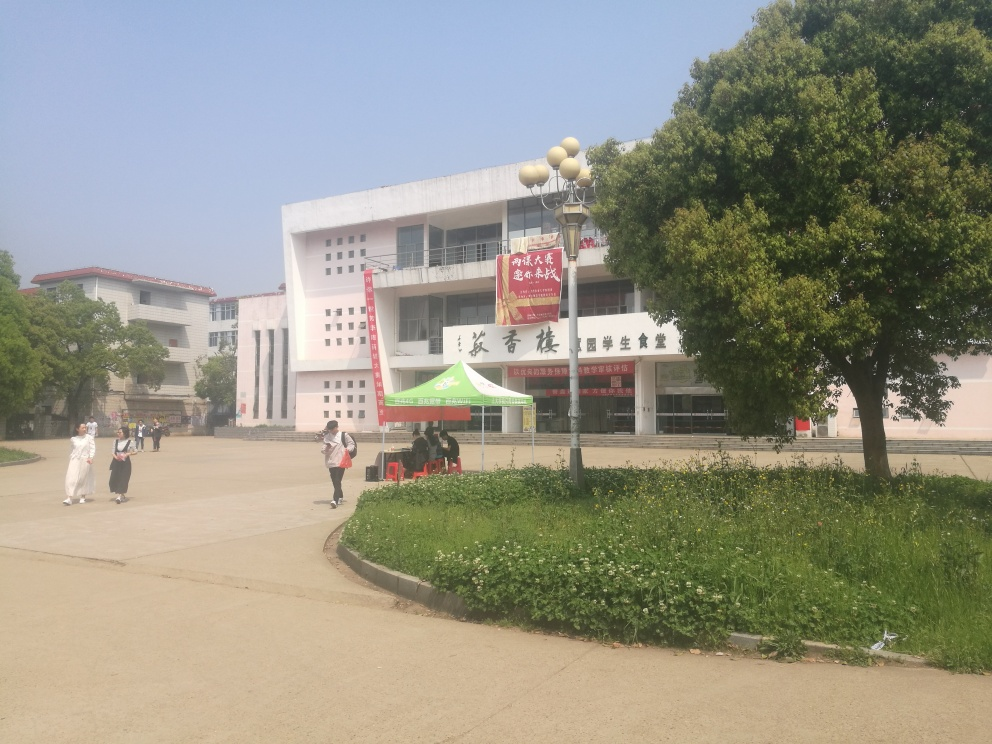How is the background in the image?
A. Cluttered background
B. Relatively clear
C. Distracting background
Answer with the option's letter from the given choices directly.
 B. 